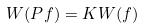Convert formula to latex. <formula><loc_0><loc_0><loc_500><loc_500>W ( P f ) = K W ( f )</formula> 